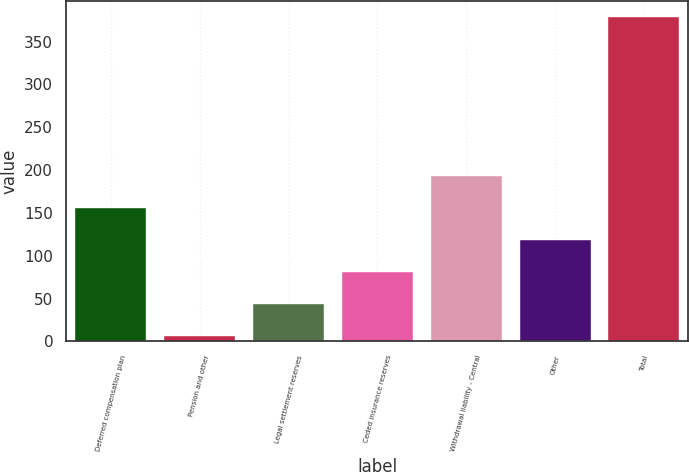<chart> <loc_0><loc_0><loc_500><loc_500><bar_chart><fcel>Deferred compensation plan<fcel>Pension and other<fcel>Legal settlement reserves<fcel>Ceded insurance reserves<fcel>Withdrawal liability - Central<fcel>Other<fcel>Total<nl><fcel>155.5<fcel>6.5<fcel>43.75<fcel>81<fcel>192.75<fcel>118.25<fcel>379<nl></chart> 